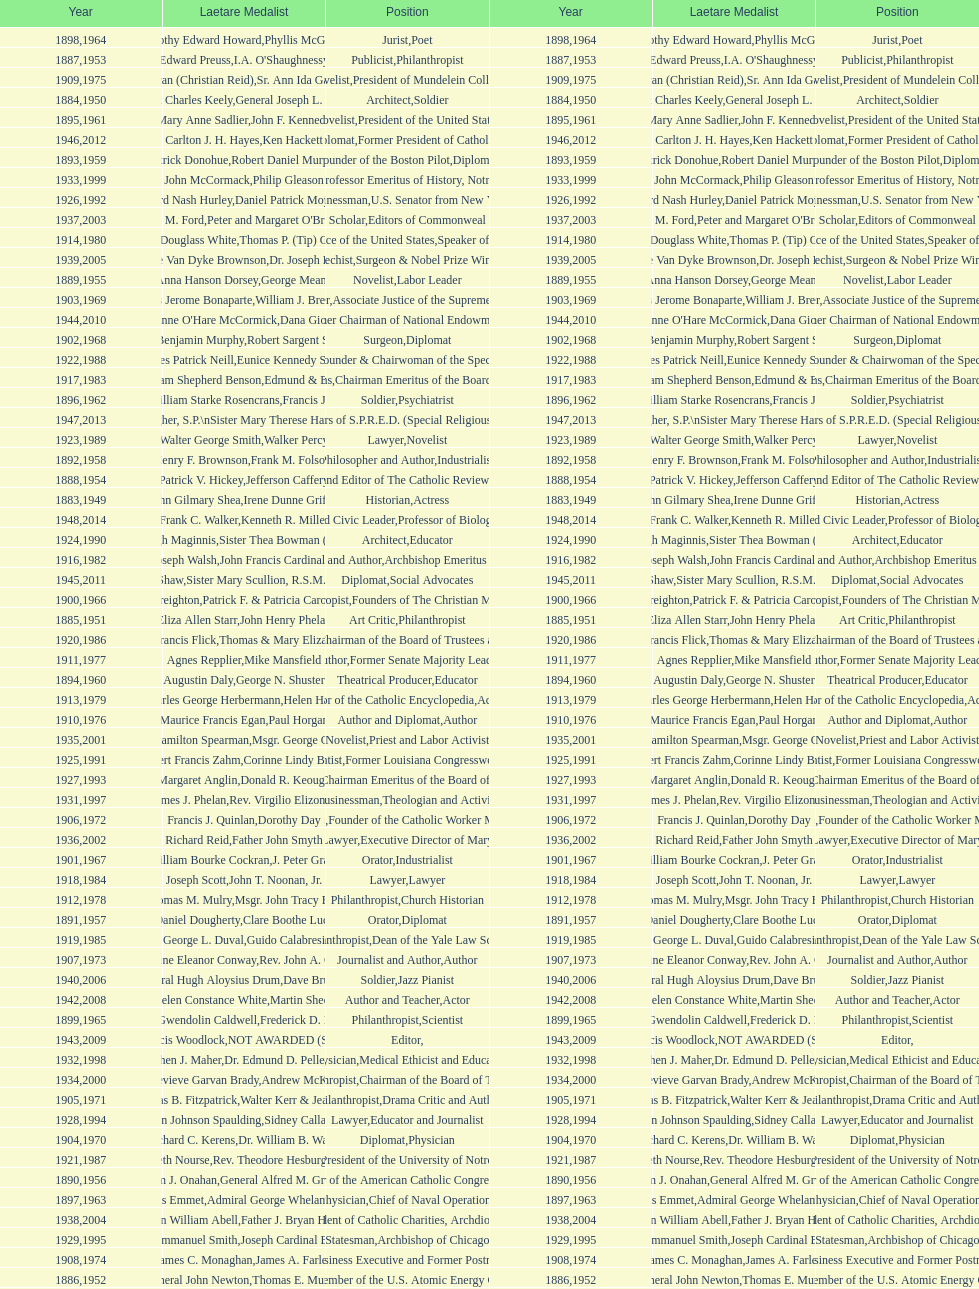Who has won this medal and the nobel prize as well? Dr. Joseph E. Murray. 